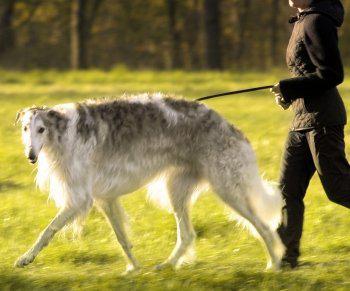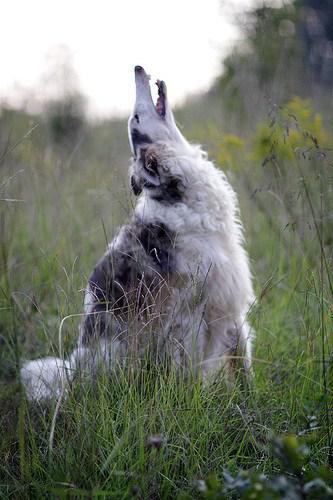The first image is the image on the left, the second image is the image on the right. Given the left and right images, does the statement "There are three hounds on the grass in total." hold true? Answer yes or no. No. 